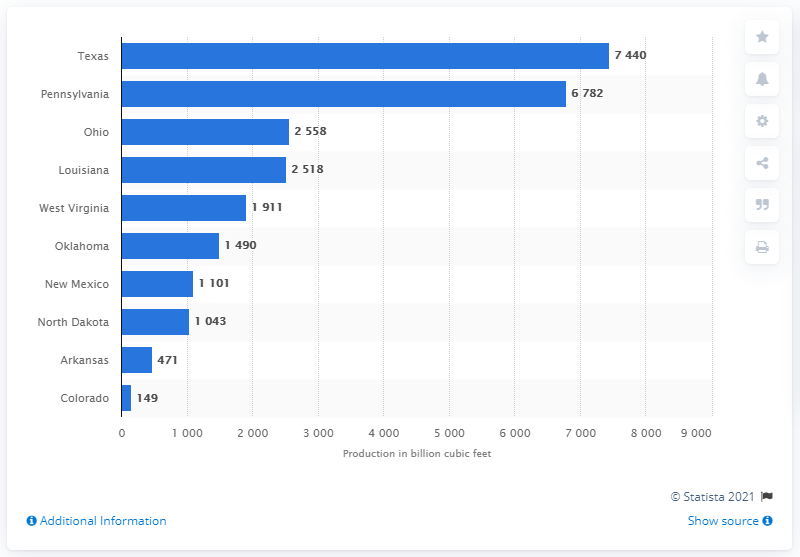Outline some significant characteristics in this image. Texas extracts the most shale gas of any US state. In 2019, the production output of shale gas in Texas was 7,440 million cubic feet. 